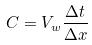<formula> <loc_0><loc_0><loc_500><loc_500>C = V _ { w } \frac { \Delta t } { \Delta x }</formula> 